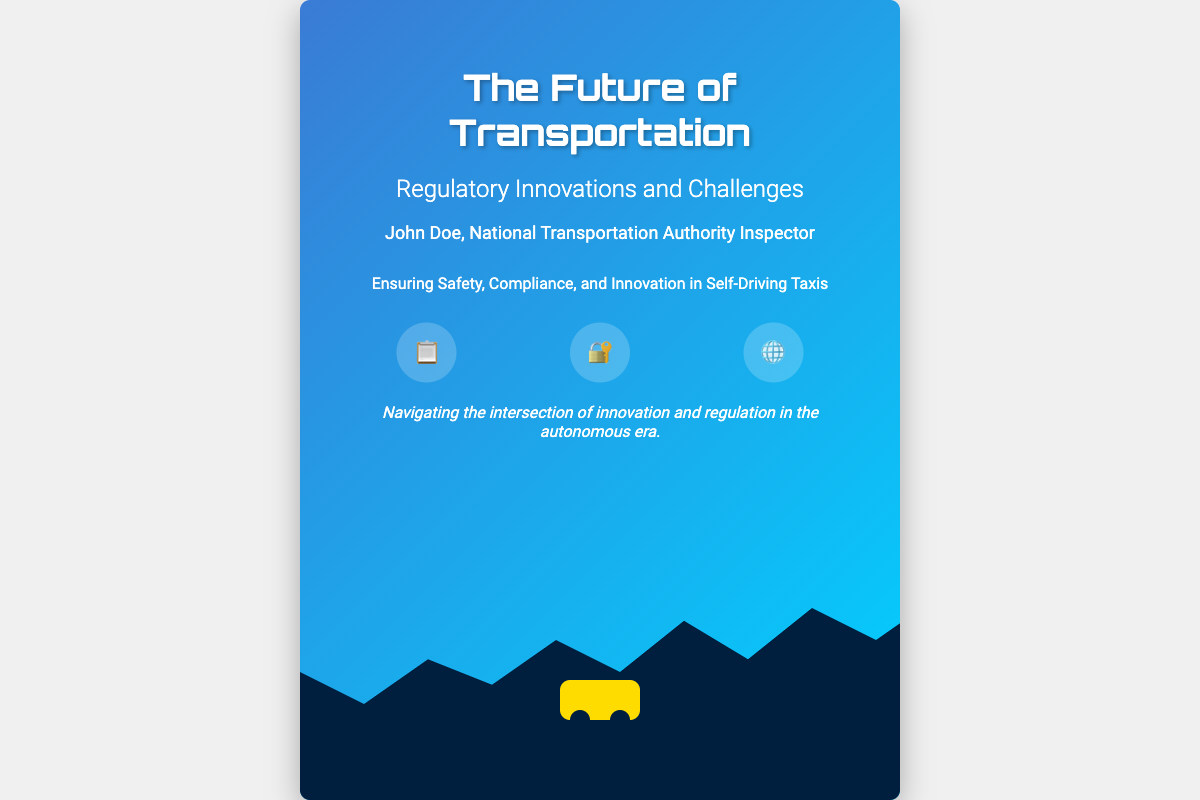What is the title of the book? The title of the book is displayed prominently at the top of the cover.
Answer: The Future of Transportation Who is the author of the book? The author is mentioned in the author section below the title.
Answer: John Doe What is the subtitle of the book? The subtitle provides more context about the content of the book under the title.
Answer: Regulatory Innovations and Challenges What is the main theme of the book? The theme is implied in the summary statement found beneath the author’s name.
Answer: Ensuring Safety, Compliance, and Innovation in Self-Driving Taxis What visual element represents transportation on the book cover? The visual element that represents transportation is illustrated in the lower section of the cover.
Answer: Taxi What are the icons present in the icons section? The icons represent different thematic ideas related to the book’s content.
Answer: 📋, 🔐, 🌐 What is the tagline of the book? The tagline summarizes the key concept addressed in the book and is found towards the bottom of the cover.
Answer: Navigating the intersection of innovation and regulation in the autonomous era Which organization does the author represent? The author's affiliation is indicated in the author section of the cover.
Answer: National Transportation Authority What element adds visual interest at the bottom of the book cover? This element contributes to the overall aesthetics of the book cover.
Answer: Cityscape 